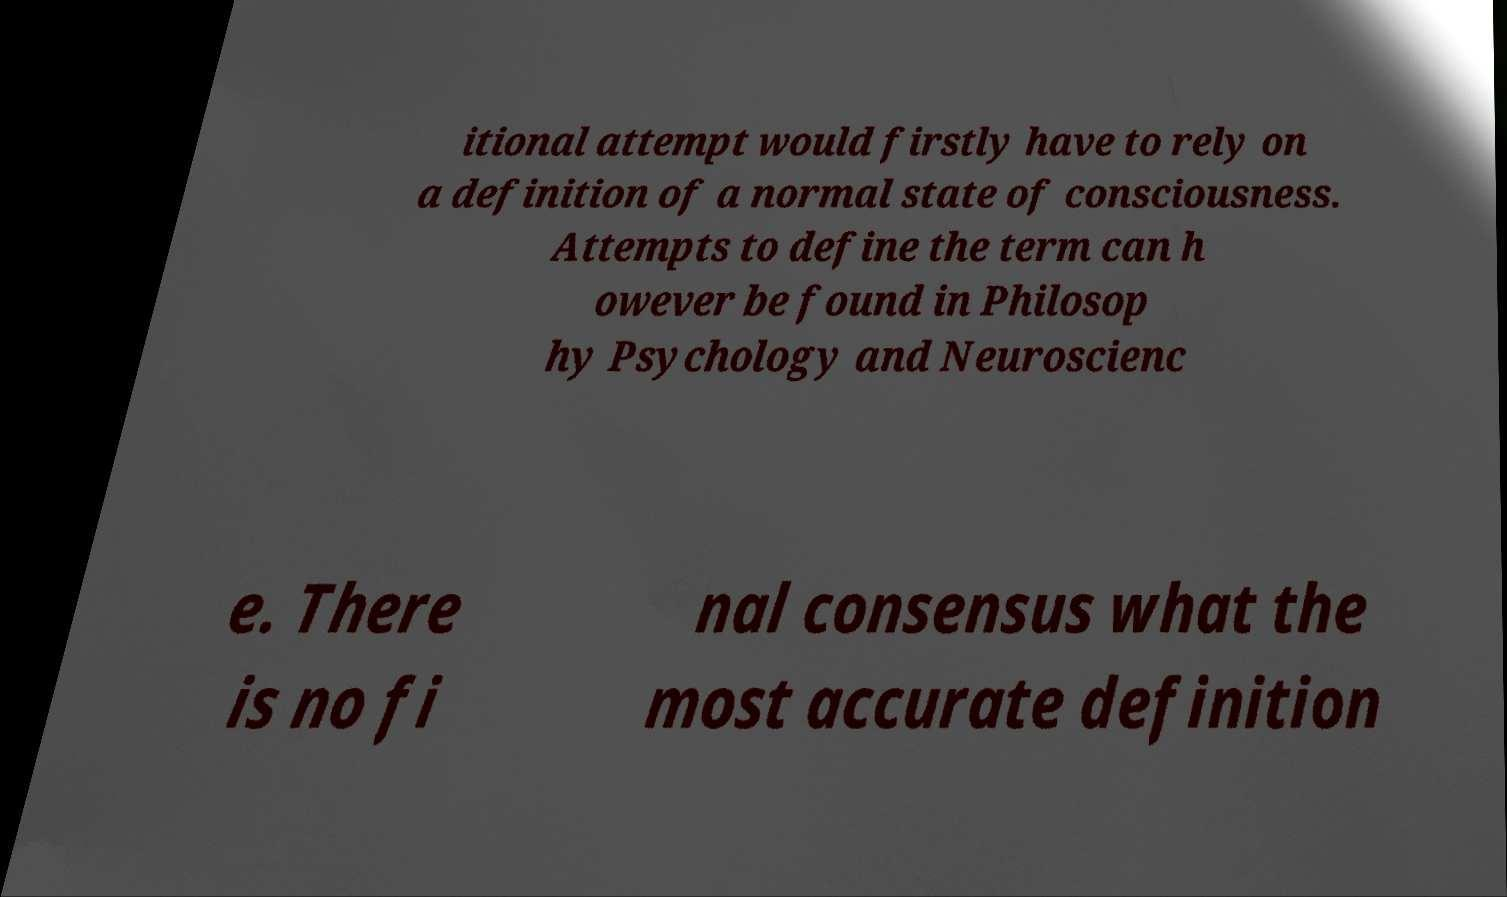Please read and relay the text visible in this image. What does it say? itional attempt would firstly have to rely on a definition of a normal state of consciousness. Attempts to define the term can h owever be found in Philosop hy Psychology and Neuroscienc e. There is no fi nal consensus what the most accurate definition 